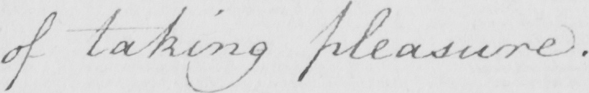What does this handwritten line say? of taking pleasure . 